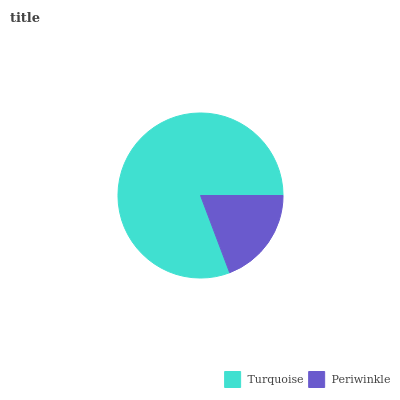Is Periwinkle the minimum?
Answer yes or no. Yes. Is Turquoise the maximum?
Answer yes or no. Yes. Is Periwinkle the maximum?
Answer yes or no. No. Is Turquoise greater than Periwinkle?
Answer yes or no. Yes. Is Periwinkle less than Turquoise?
Answer yes or no. Yes. Is Periwinkle greater than Turquoise?
Answer yes or no. No. Is Turquoise less than Periwinkle?
Answer yes or no. No. Is Turquoise the high median?
Answer yes or no. Yes. Is Periwinkle the low median?
Answer yes or no. Yes. Is Periwinkle the high median?
Answer yes or no. No. Is Turquoise the low median?
Answer yes or no. No. 